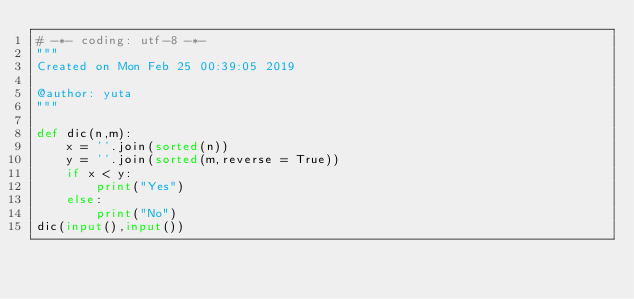<code> <loc_0><loc_0><loc_500><loc_500><_Python_># -*- coding: utf-8 -*-
"""
Created on Mon Feb 25 00:39:05 2019

@author: yuta
"""

def dic(n,m):
    x = ''.join(sorted(n))
    y = ''.join(sorted(m,reverse = True))
    if x < y:
        print("Yes")
    else:
        print("No")
dic(input(),input())</code> 